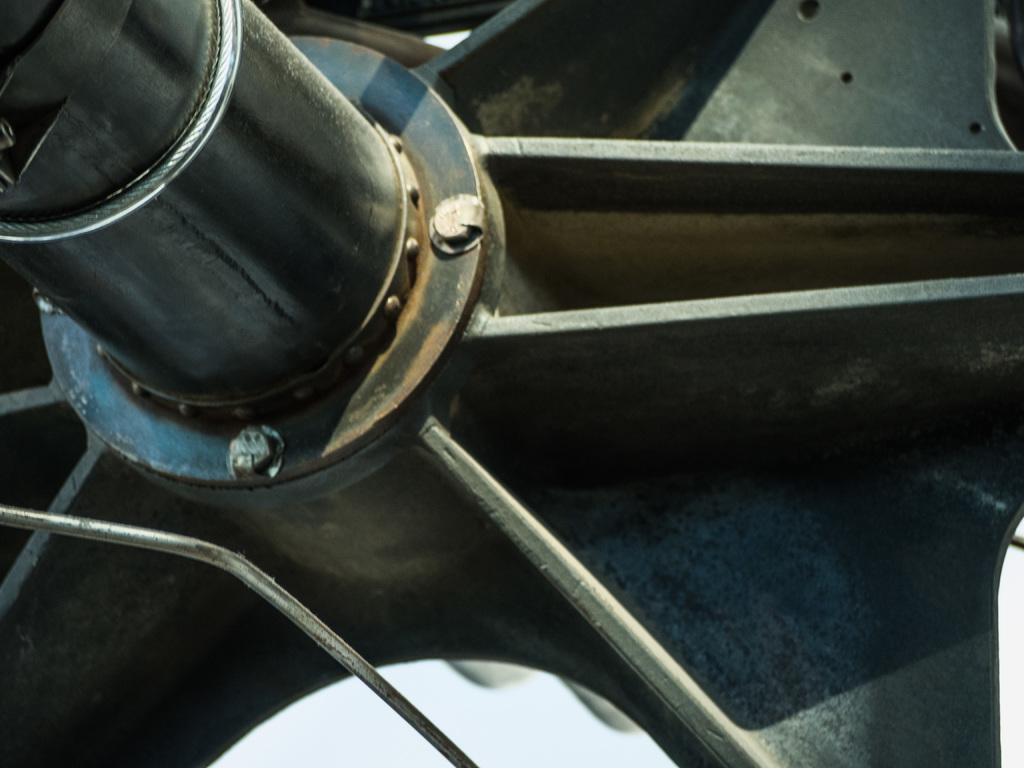What type of wheel is depicted in the image? There is an iron wheel in the image. What statement is being exchanged between the iron wheel and the order in the image? There is no statement being exchanged or order present in the image, as it only features an iron wheel. 